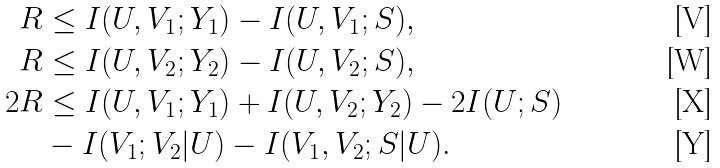Convert formula to latex. <formula><loc_0><loc_0><loc_500><loc_500>R & \leq I ( U , V _ { 1 } ; Y _ { 1 } ) - I ( U , V _ { 1 } ; S ) , \\ R & \leq I ( U , V _ { 2 } ; Y _ { 2 } ) - I ( U , V _ { 2 } ; S ) , \\ 2 R & \leq I ( U , V _ { 1 } ; Y _ { 1 } ) + I ( U , V _ { 2 } ; Y _ { 2 } ) - 2 I ( U ; S ) \\ & - I ( V _ { 1 } ; V _ { 2 } | U ) - I ( V _ { 1 } , V _ { 2 } ; S | U ) .</formula> 